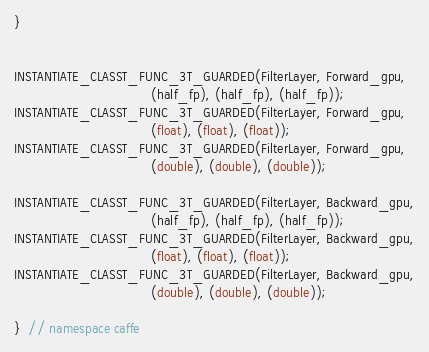Convert code to text. <code><loc_0><loc_0><loc_500><loc_500><_Cuda_>}


INSTANTIATE_CLASST_FUNC_3T_GUARDED(FilterLayer, Forward_gpu,
                                  (half_fp), (half_fp), (half_fp));
INSTANTIATE_CLASST_FUNC_3T_GUARDED(FilterLayer, Forward_gpu,
                                  (float), (float), (float));
INSTANTIATE_CLASST_FUNC_3T_GUARDED(FilterLayer, Forward_gpu,
                                  (double), (double), (double));

INSTANTIATE_CLASST_FUNC_3T_GUARDED(FilterLayer, Backward_gpu,
                                  (half_fp), (half_fp), (half_fp));
INSTANTIATE_CLASST_FUNC_3T_GUARDED(FilterLayer, Backward_gpu,
                                  (float), (float), (float));
INSTANTIATE_CLASST_FUNC_3T_GUARDED(FilterLayer, Backward_gpu,
                                  (double), (double), (double));

}  // namespace caffe
</code> 